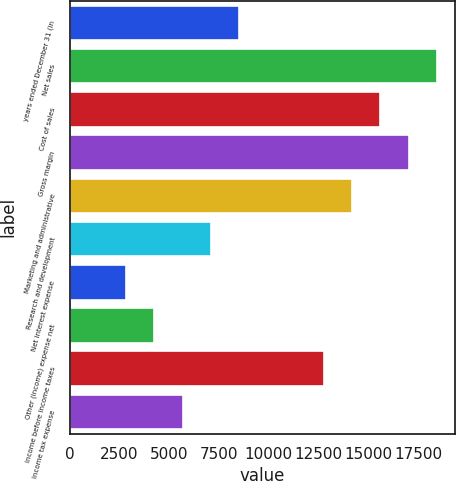Convert chart. <chart><loc_0><loc_0><loc_500><loc_500><bar_chart><fcel>years ended December 31 (in<fcel>Net sales<fcel>Cost of sales<fcel>Gross margin<fcel>Marketing and administrative<fcel>Research and development<fcel>Net interest expense<fcel>Other (income) expense net<fcel>Income before income taxes<fcel>Income tax expense<nl><fcel>8515.66<fcel>18445.7<fcel>15608.6<fcel>17027.1<fcel>14190<fcel>7097.08<fcel>2841.34<fcel>4259.92<fcel>12771.4<fcel>5678.5<nl></chart> 